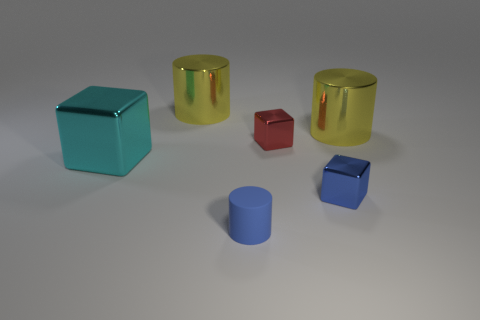Add 2 cyan matte spheres. How many objects exist? 8 Subtract 1 red cubes. How many objects are left? 5 Subtract all small matte things. Subtract all blue metal things. How many objects are left? 4 Add 6 small blue cylinders. How many small blue cylinders are left? 7 Add 6 large cyan metallic cubes. How many large cyan metallic cubes exist? 7 